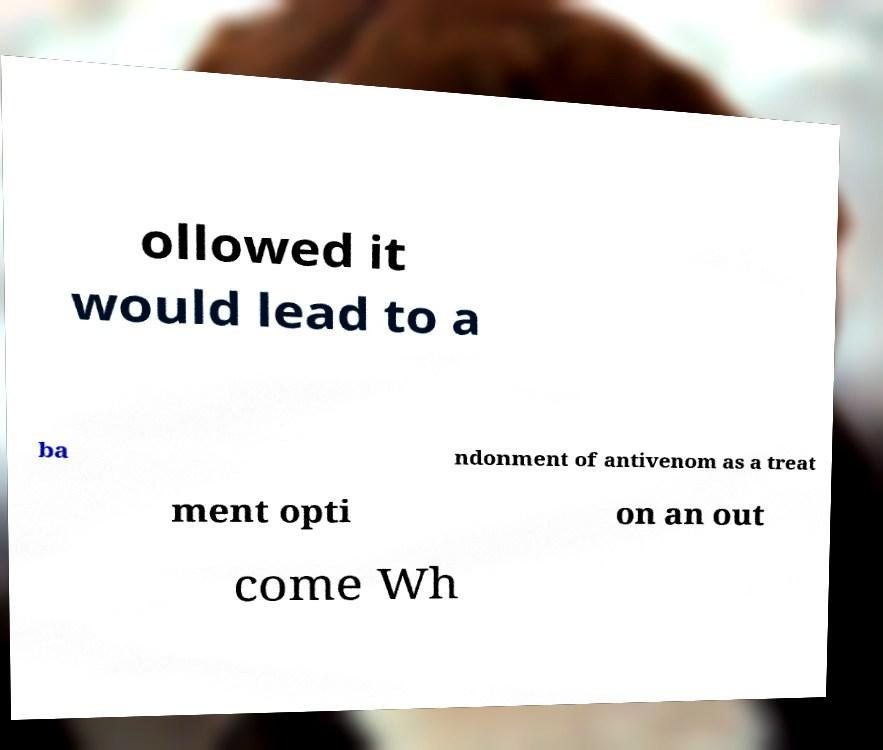Please read and relay the text visible in this image. What does it say? ollowed it would lead to a ba ndonment of antivenom as a treat ment opti on an out come Wh 